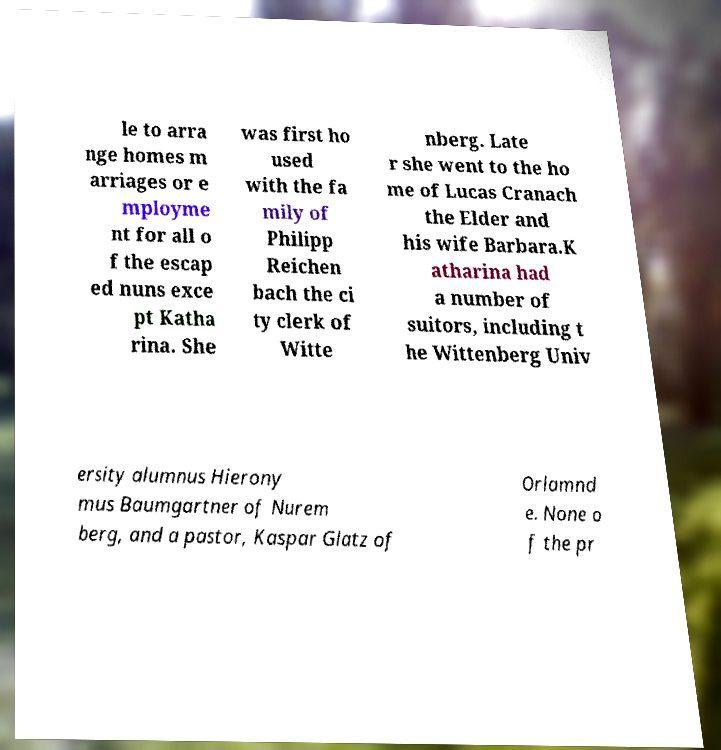Can you read and provide the text displayed in the image?This photo seems to have some interesting text. Can you extract and type it out for me? le to arra nge homes m arriages or e mployme nt for all o f the escap ed nuns exce pt Katha rina. She was first ho used with the fa mily of Philipp Reichen bach the ci ty clerk of Witte nberg. Late r she went to the ho me of Lucas Cranach the Elder and his wife Barbara.K atharina had a number of suitors, including t he Wittenberg Univ ersity alumnus Hierony mus Baumgartner of Nurem berg, and a pastor, Kaspar Glatz of Orlamnd e. None o f the pr 